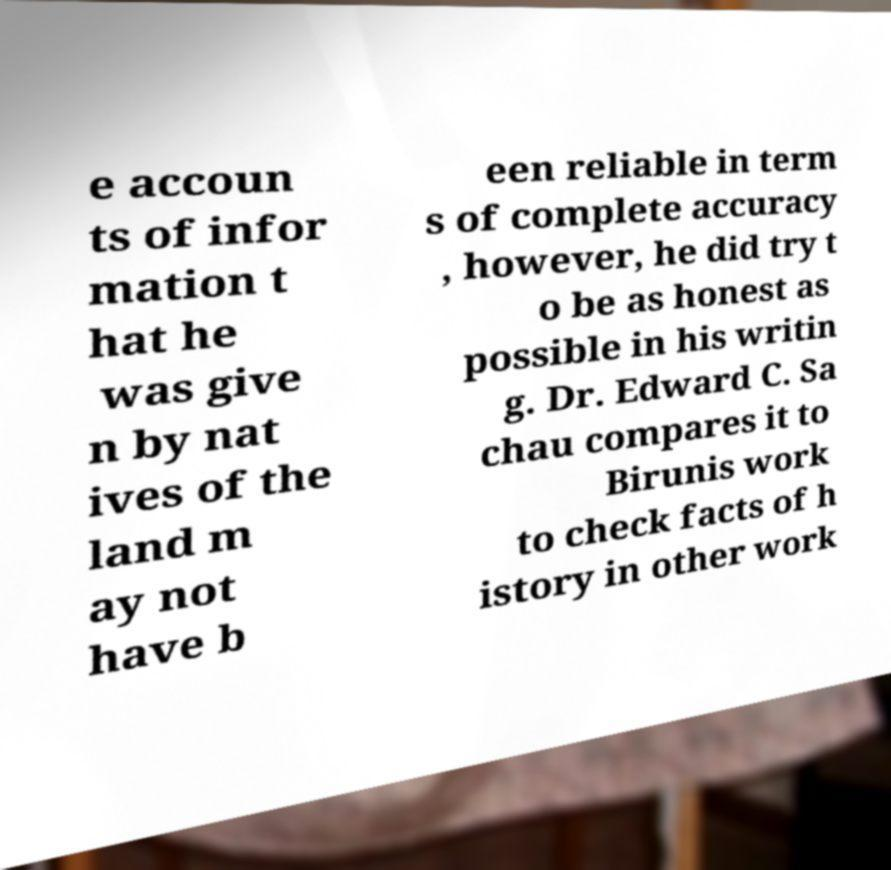Could you assist in decoding the text presented in this image and type it out clearly? e accoun ts of infor mation t hat he was give n by nat ives of the land m ay not have b een reliable in term s of complete accuracy , however, he did try t o be as honest as possible in his writin g. Dr. Edward C. Sa chau compares it to Birunis work to check facts of h istory in other work 